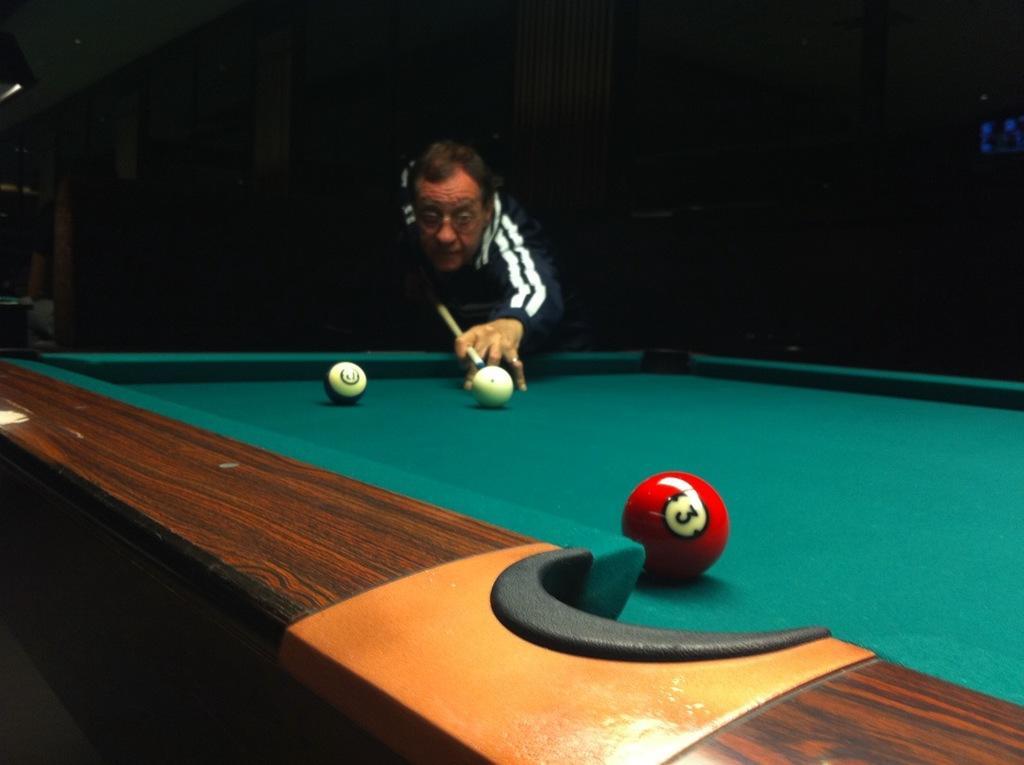Describe this image in one or two sentences. In this image, man is holding a stick, he is playing a pool game. There are few balls are placed on the green color table. And back side, we can see a wall, few peoples are here. 